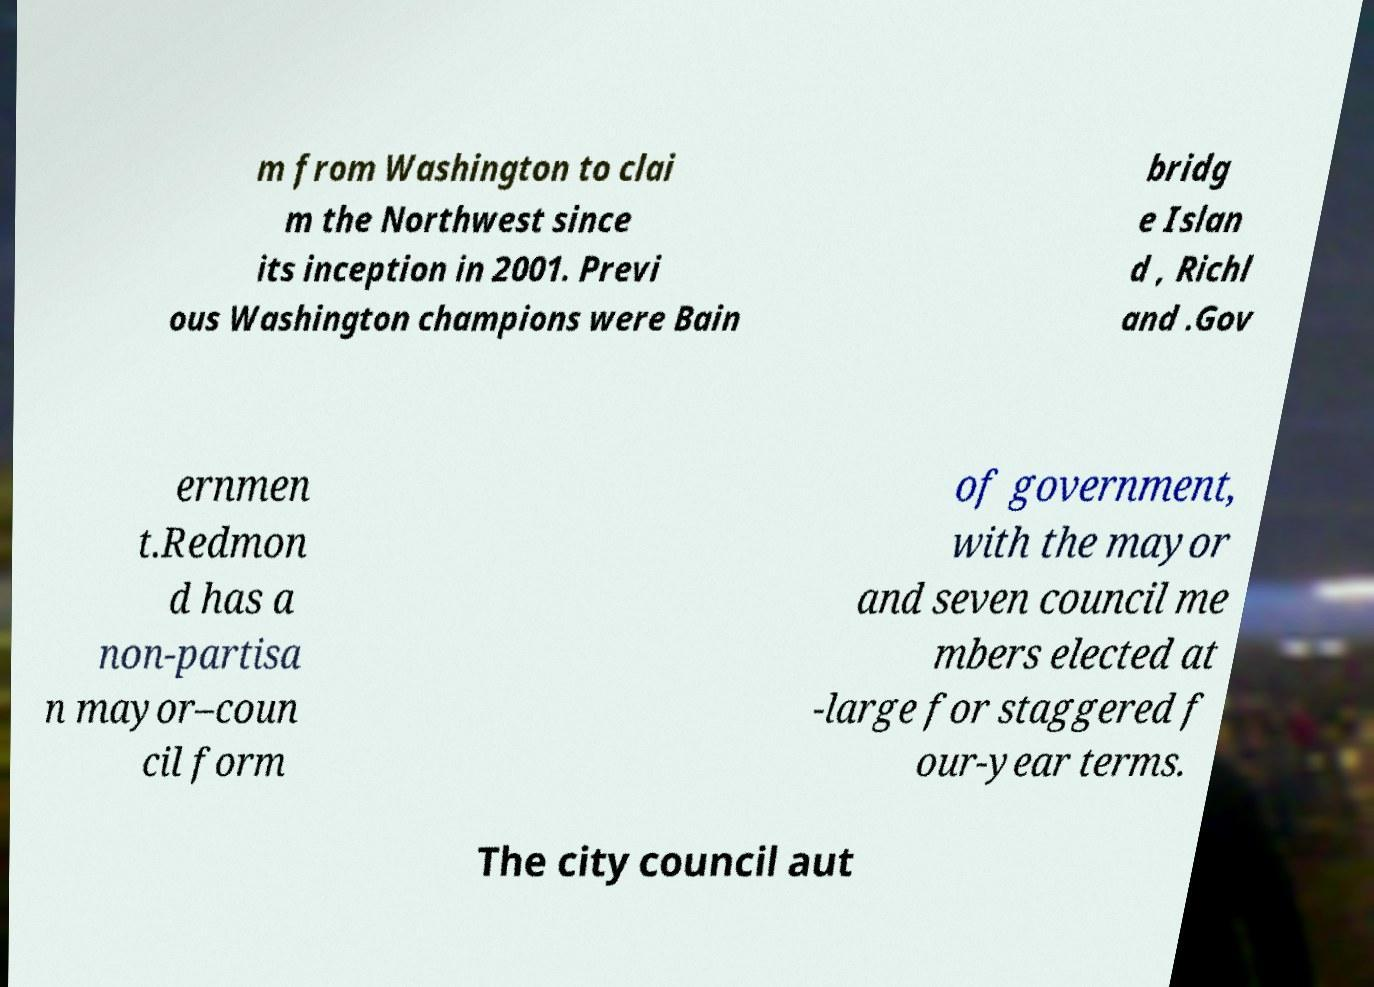Could you assist in decoding the text presented in this image and type it out clearly? m from Washington to clai m the Northwest since its inception in 2001. Previ ous Washington champions were Bain bridg e Islan d , Richl and .Gov ernmen t.Redmon d has a non-partisa n mayor–coun cil form of government, with the mayor and seven council me mbers elected at -large for staggered f our-year terms. The city council aut 